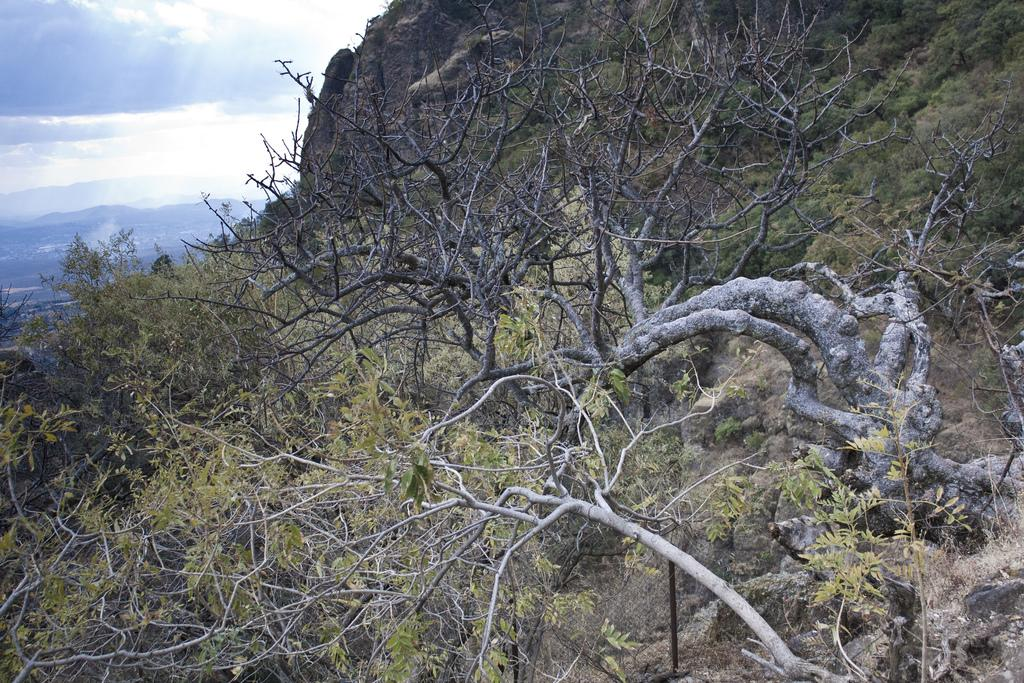What type of landscape is depicted in the image? The image features hills. What other natural elements can be seen in the image? There are trees in the image. What is visible in the sky in the top left corner of the image? Clouds are visible in the sky in the top left corner of the image. What type of caption is written on the image? There is no caption present in the image. How many beans are scattered on the ground in the image? There are no beans visible in the image. 